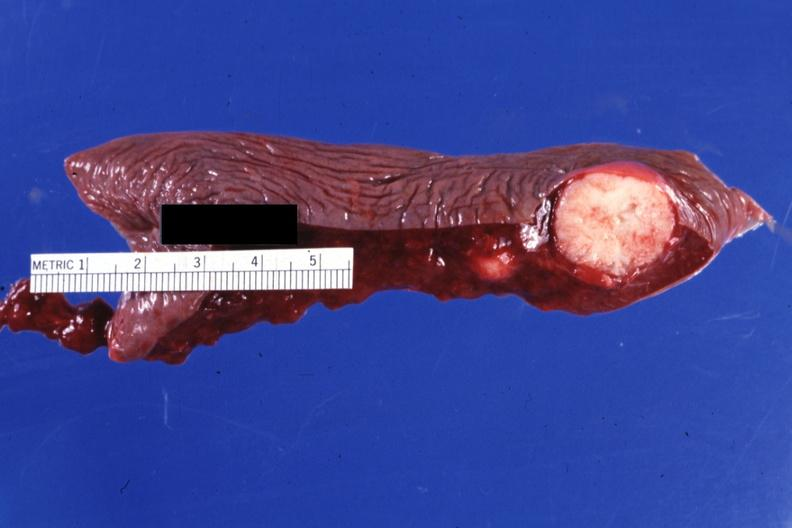s metastatic carcinoma breast present?
Answer the question using a single word or phrase. Yes 